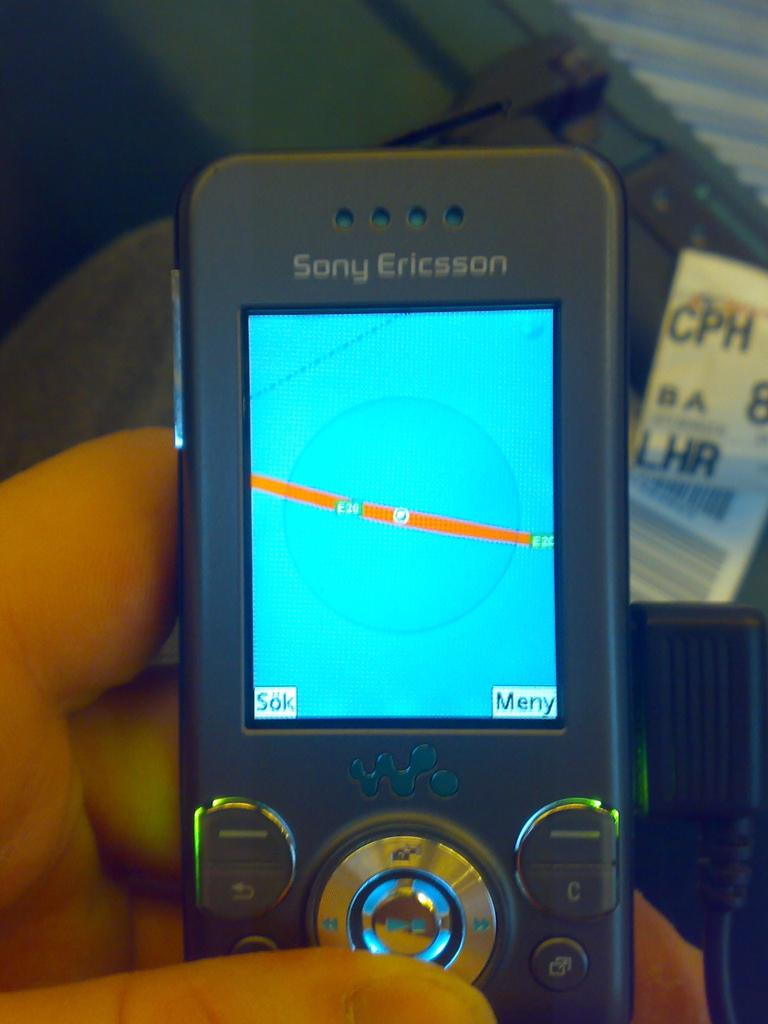<image>
Relay a brief, clear account of the picture shown. An antiquated black cell phone made by Sony Ericsson. 